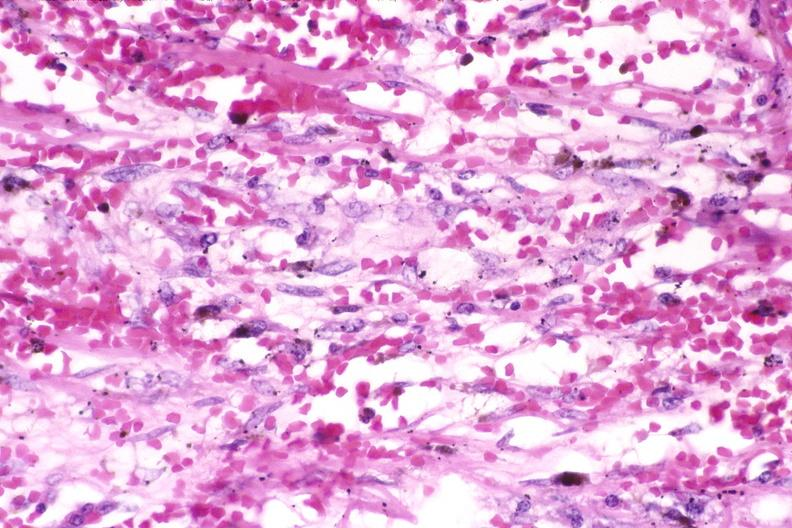does close-up of lesion show skin, kaposis 's sarcoma?
Answer the question using a single word or phrase. No 